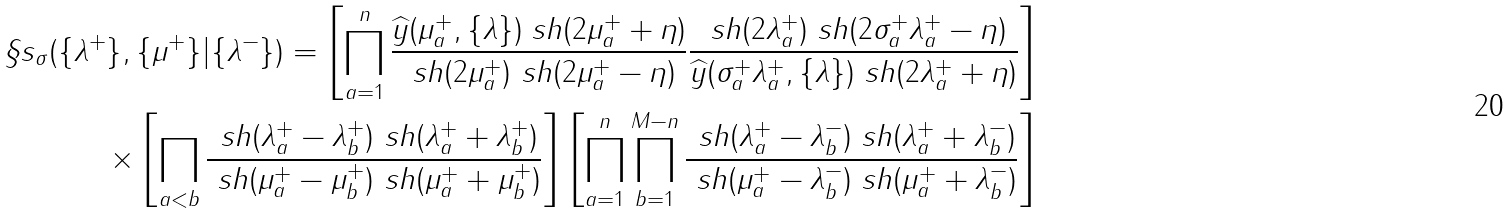<formula> <loc_0><loc_0><loc_500><loc_500>\S s _ { \sigma } ( \{ \lambda ^ { + } \} , \{ \mu ^ { + } \} | \{ \lambda ^ { - } \} ) = \left [ \prod _ { a = 1 } ^ { n } \frac { \widehat { y } ( \mu _ { a } ^ { + } , \{ \lambda \} ) \ s h ( 2 \mu _ { a } ^ { + } + \eta ) } { \ s h ( 2 \mu _ { a } ^ { + } ) \ s h ( 2 \mu _ { a } ^ { + } - \eta ) } \frac { \ s h ( 2 \lambda _ { a } ^ { + } ) \ s h ( 2 \sigma _ { a } ^ { + } \lambda _ { a } ^ { + } - \eta ) } { \widehat { y } ( \sigma _ { a } ^ { + } \lambda _ { a } ^ { + } , \{ \lambda \} ) \ s h ( 2 \lambda _ { a } ^ { + } + \eta ) } \right ] & \\ \times \left [ \prod _ { a < b } \frac { \ s h ( \lambda _ { a } ^ { + } - \lambda _ { b } ^ { + } ) \ s h ( \lambda _ { a } ^ { + } + \lambda _ { b } ^ { + } ) } { \ s h ( \mu _ { a } ^ { + } - \mu _ { b } ^ { + } ) \ s h ( \mu _ { a } ^ { + } + \mu _ { b } ^ { + } ) } \right ] \left [ \prod _ { a = 1 } ^ { n } \prod _ { b = 1 } ^ { M - n } \frac { \ s h ( \lambda _ { a } ^ { + } - \lambda _ { b } ^ { - } ) \ s h ( \lambda _ { a } ^ { + } + \lambda _ { b } ^ { - } ) } { \ s h ( \mu _ { a } ^ { + } - \lambda _ { b } ^ { - } ) \ s h ( \mu _ { a } ^ { + } + \lambda _ { b } ^ { - } ) } \right ]</formula> 